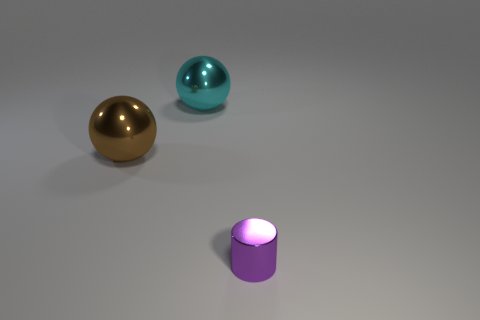Are there any other things that have the same size as the metal cylinder?
Make the answer very short. No. How big is the ball left of the cyan shiny object?
Offer a terse response. Large. The small purple object has what shape?
Your answer should be very brief. Cylinder. There is a thing in front of the brown metallic ball; is its size the same as the shiny ball that is in front of the large cyan shiny thing?
Provide a succinct answer. No. There is a metal sphere that is left of the ball behind the shiny ball left of the cyan metal thing; what is its size?
Provide a short and direct response. Large. The thing that is to the right of the metal thing behind the big metal ball that is on the left side of the big cyan thing is what shape?
Keep it short and to the point. Cylinder. What is the shape of the big thing left of the cyan thing?
Offer a terse response. Sphere. Is the material of the brown ball the same as the thing that is to the right of the large cyan sphere?
Provide a succinct answer. Yes. What number of other objects are the same shape as the brown shiny object?
Provide a succinct answer. 1. The big thing right of the big brown metallic object that is to the left of the large cyan sphere is what shape?
Provide a short and direct response. Sphere. 